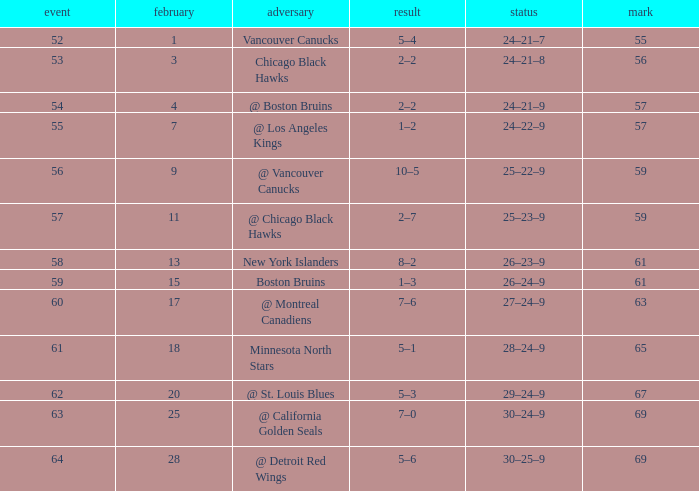How many games have a record of 30–25–9 and more points than 69? 0.0. 